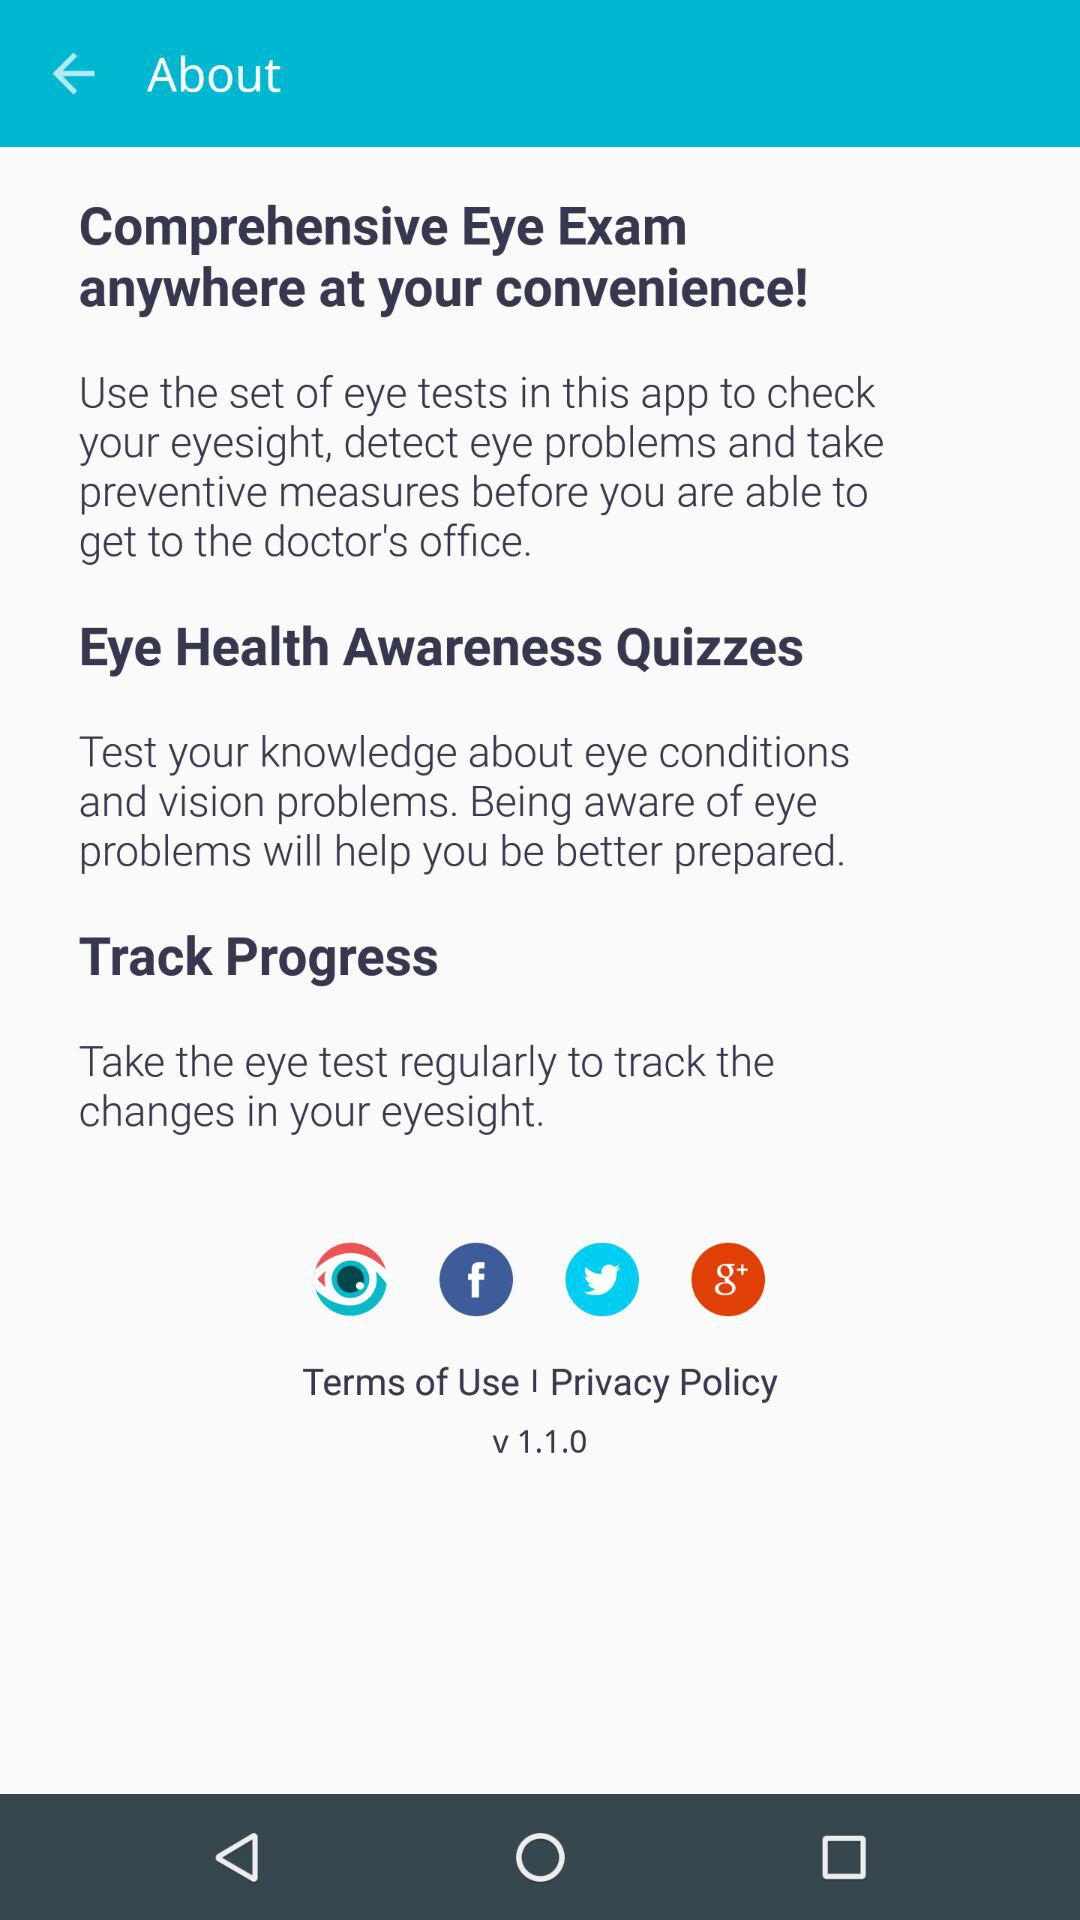What is the version given?v The version is "v 1.1.0". 